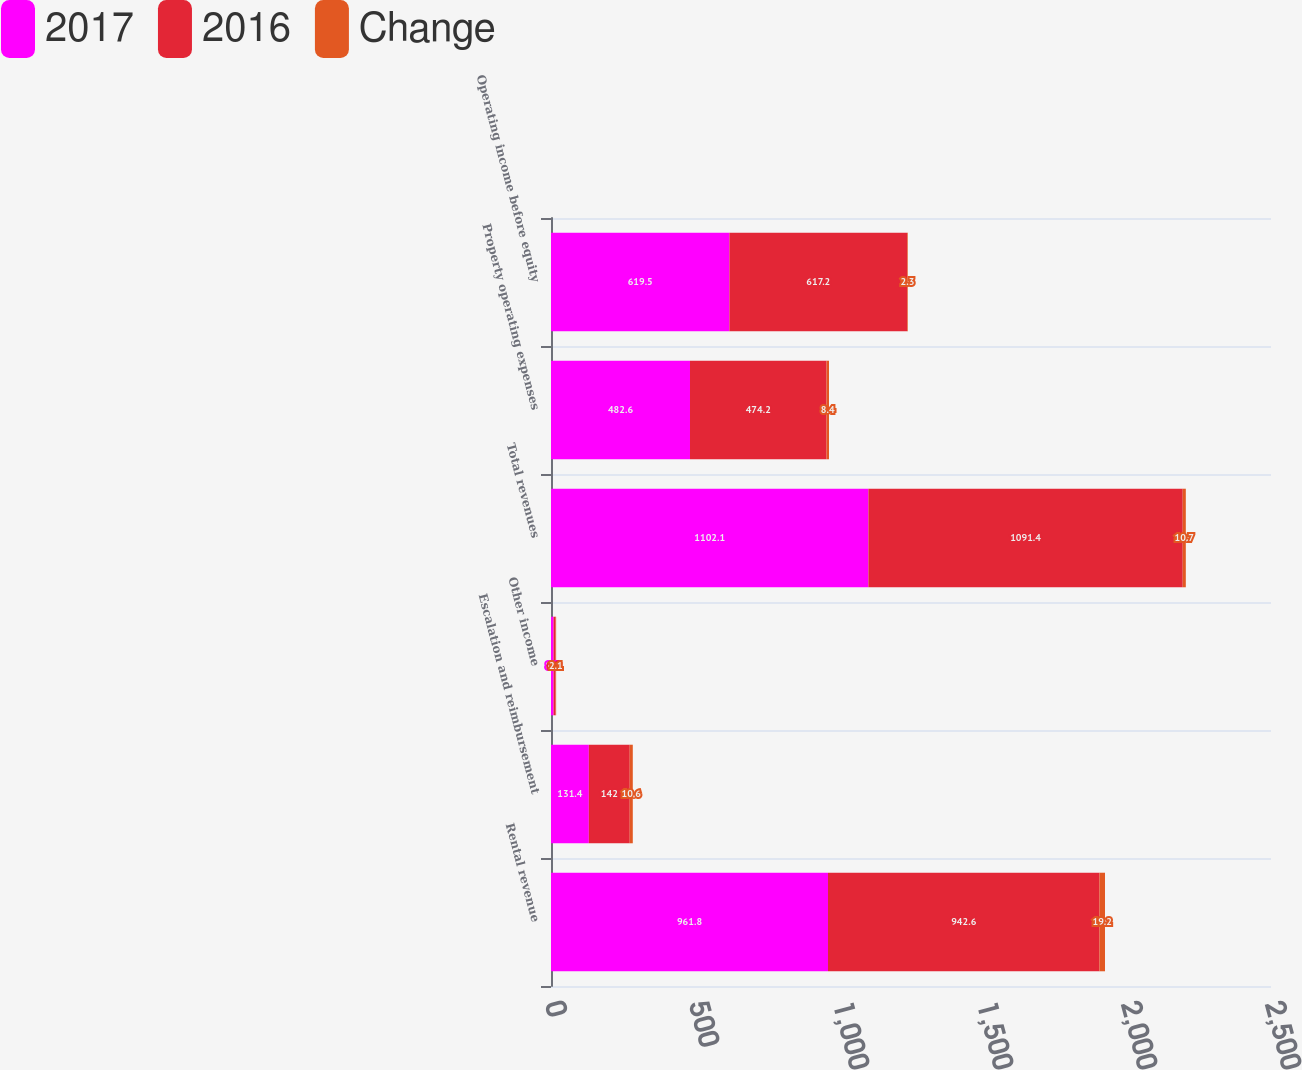<chart> <loc_0><loc_0><loc_500><loc_500><stacked_bar_chart><ecel><fcel>Rental revenue<fcel>Escalation and reimbursement<fcel>Other income<fcel>Total revenues<fcel>Property operating expenses<fcel>Operating income before equity<nl><fcel>2017<fcel>961.8<fcel>131.4<fcel>8.9<fcel>1102.1<fcel>482.6<fcel>619.5<nl><fcel>2016<fcel>942.6<fcel>142<fcel>6.8<fcel>1091.4<fcel>474.2<fcel>617.2<nl><fcel>Change<fcel>19.2<fcel>10.6<fcel>2.1<fcel>10.7<fcel>8.4<fcel>2.3<nl></chart> 